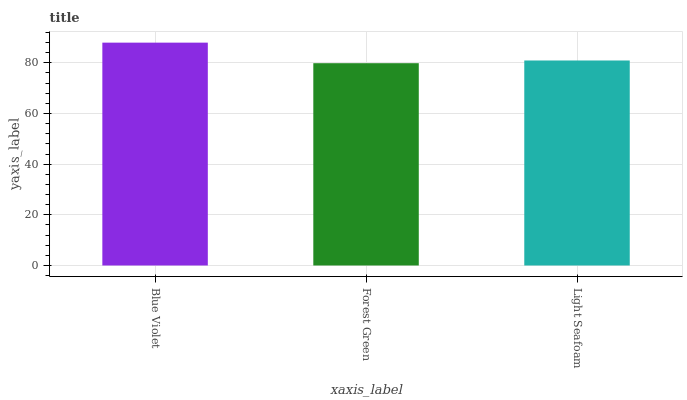Is Forest Green the minimum?
Answer yes or no. Yes. Is Blue Violet the maximum?
Answer yes or no. Yes. Is Light Seafoam the minimum?
Answer yes or no. No. Is Light Seafoam the maximum?
Answer yes or no. No. Is Light Seafoam greater than Forest Green?
Answer yes or no. Yes. Is Forest Green less than Light Seafoam?
Answer yes or no. Yes. Is Forest Green greater than Light Seafoam?
Answer yes or no. No. Is Light Seafoam less than Forest Green?
Answer yes or no. No. Is Light Seafoam the high median?
Answer yes or no. Yes. Is Light Seafoam the low median?
Answer yes or no. Yes. Is Blue Violet the high median?
Answer yes or no. No. Is Blue Violet the low median?
Answer yes or no. No. 